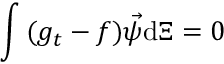Convert formula to latex. <formula><loc_0><loc_0><loc_500><loc_500>\int { ( g _ { t } - f ) \vec { \psi } d \Xi } = 0</formula> 